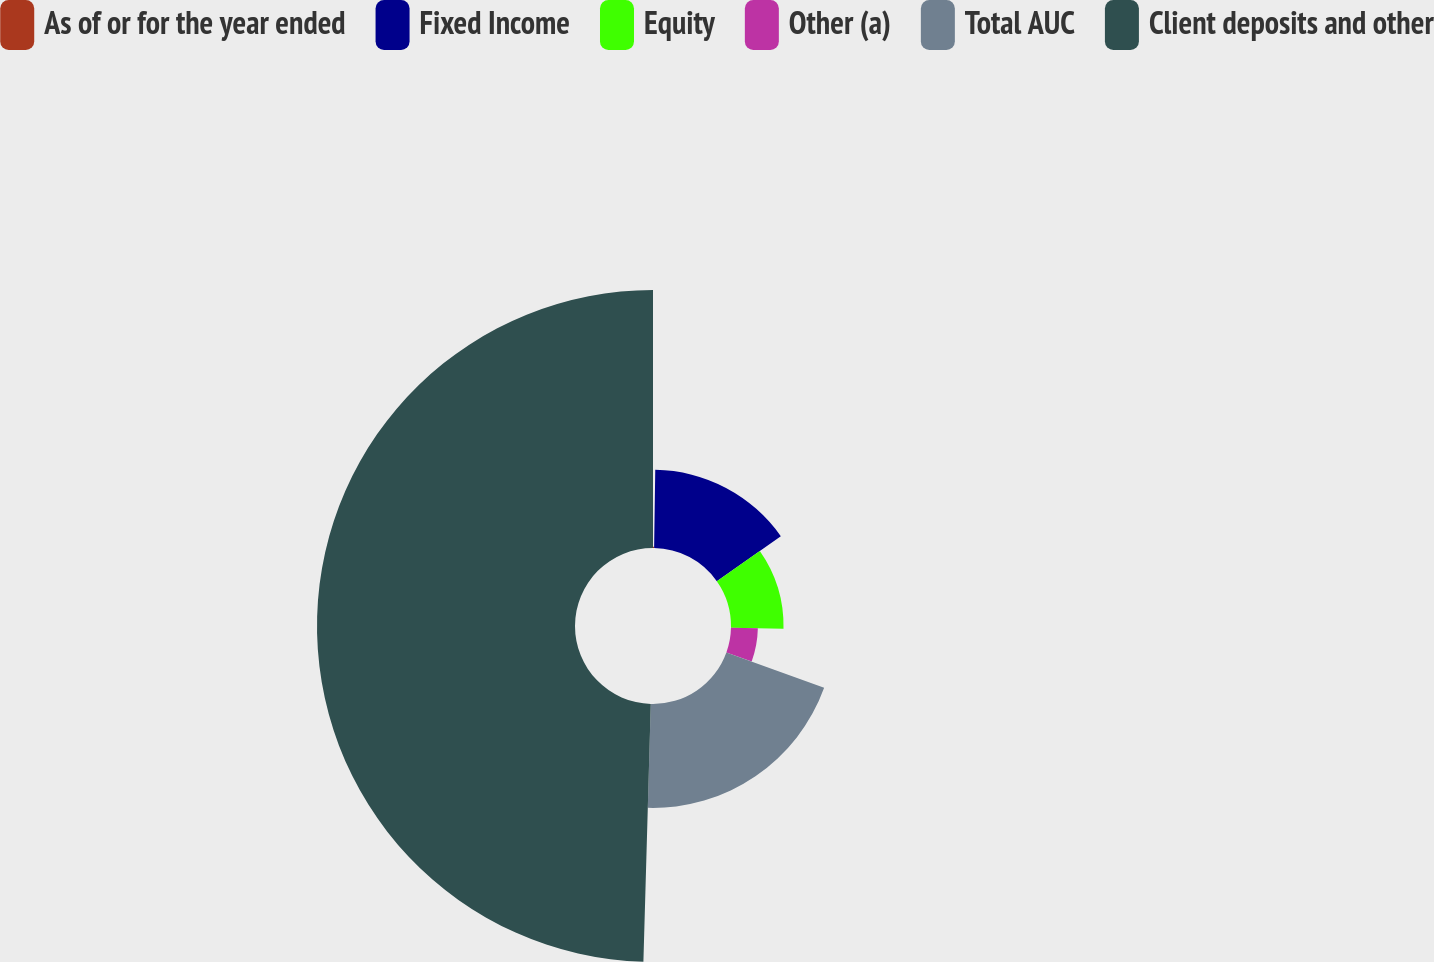Convert chart to OTSL. <chart><loc_0><loc_0><loc_500><loc_500><pie_chart><fcel>As of or for the year ended<fcel>Fixed Income<fcel>Equity<fcel>Other (a)<fcel>Total AUC<fcel>Client deposits and other<nl><fcel>0.23%<fcel>15.02%<fcel>10.09%<fcel>5.16%<fcel>19.95%<fcel>49.54%<nl></chart> 